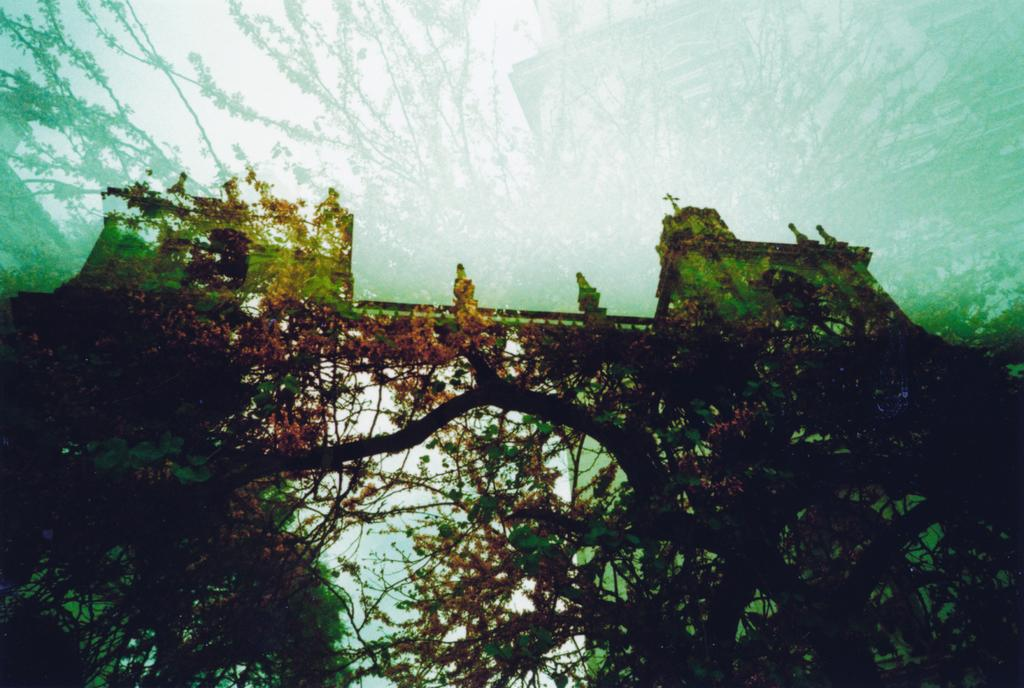What type of natural elements can be seen in the image? There are trees in the image. What man-made structure is present in the image? There is a historical construction in the image. Is there any architectural feature associated with the historical construction? Yes, there is a bridge associated with the historical construction. What type of pets can be seen playing on the bridge in the image? There are no pets present in the image, and the bridge is not depicted as a play area for animals. 